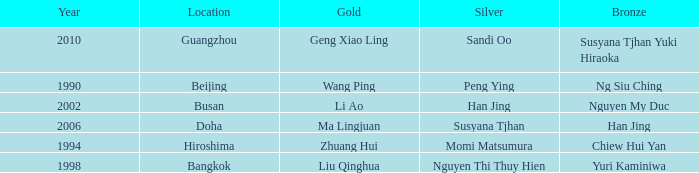What's the Bronze with the Year of 1998? Yuri Kaminiwa. 